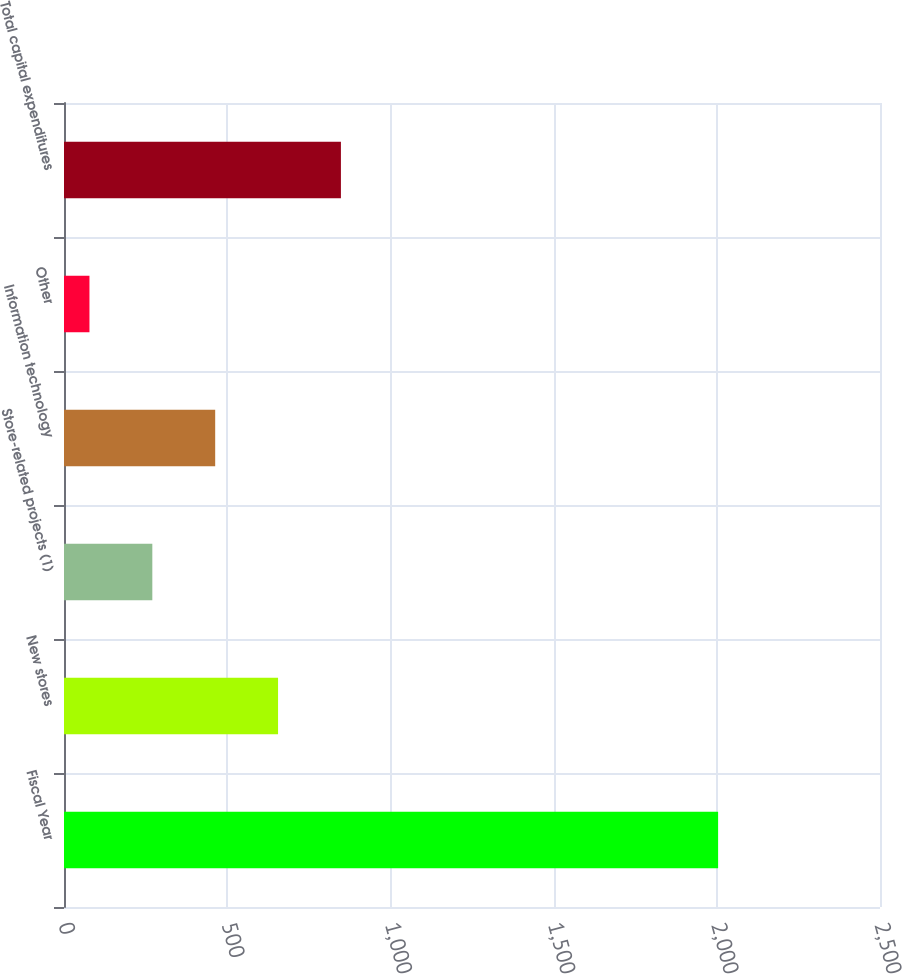<chart> <loc_0><loc_0><loc_500><loc_500><bar_chart><fcel>Fiscal Year<fcel>New stores<fcel>Store-related projects (1)<fcel>Information technology<fcel>Other<fcel>Total capital expenditures<nl><fcel>2004<fcel>655.8<fcel>270.6<fcel>463.2<fcel>78<fcel>848.4<nl></chart> 